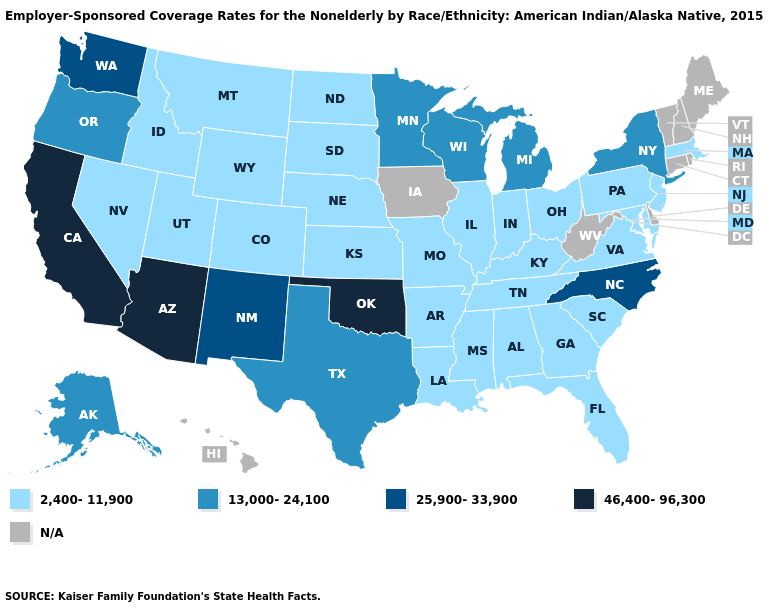Name the states that have a value in the range 25,900-33,900?
Answer briefly. New Mexico, North Carolina, Washington. Does New Jersey have the lowest value in the Northeast?
Write a very short answer. Yes. What is the highest value in the USA?
Keep it brief. 46,400-96,300. Name the states that have a value in the range 25,900-33,900?
Write a very short answer. New Mexico, North Carolina, Washington. Among the states that border Iowa , does Minnesota have the highest value?
Write a very short answer. Yes. Name the states that have a value in the range 13,000-24,100?
Concise answer only. Alaska, Michigan, Minnesota, New York, Oregon, Texas, Wisconsin. Name the states that have a value in the range N/A?
Write a very short answer. Connecticut, Delaware, Hawaii, Iowa, Maine, New Hampshire, Rhode Island, Vermont, West Virginia. What is the value of Pennsylvania?
Give a very brief answer. 2,400-11,900. Does Oklahoma have the highest value in the USA?
Concise answer only. Yes. Name the states that have a value in the range 25,900-33,900?
Quick response, please. New Mexico, North Carolina, Washington. What is the lowest value in the USA?
Give a very brief answer. 2,400-11,900. Among the states that border Pennsylvania , does Maryland have the lowest value?
Be succinct. Yes. What is the value of Connecticut?
Be succinct. N/A. 